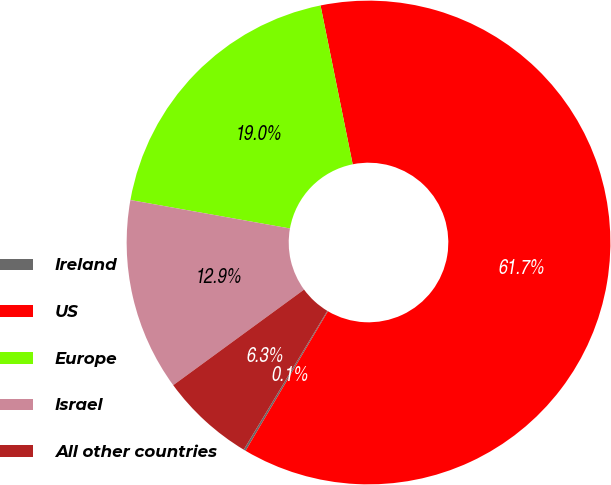Convert chart to OTSL. <chart><loc_0><loc_0><loc_500><loc_500><pie_chart><fcel>Ireland<fcel>US<fcel>Europe<fcel>Israel<fcel>All other countries<nl><fcel>0.14%<fcel>61.66%<fcel>19.01%<fcel>12.85%<fcel>6.33%<nl></chart> 